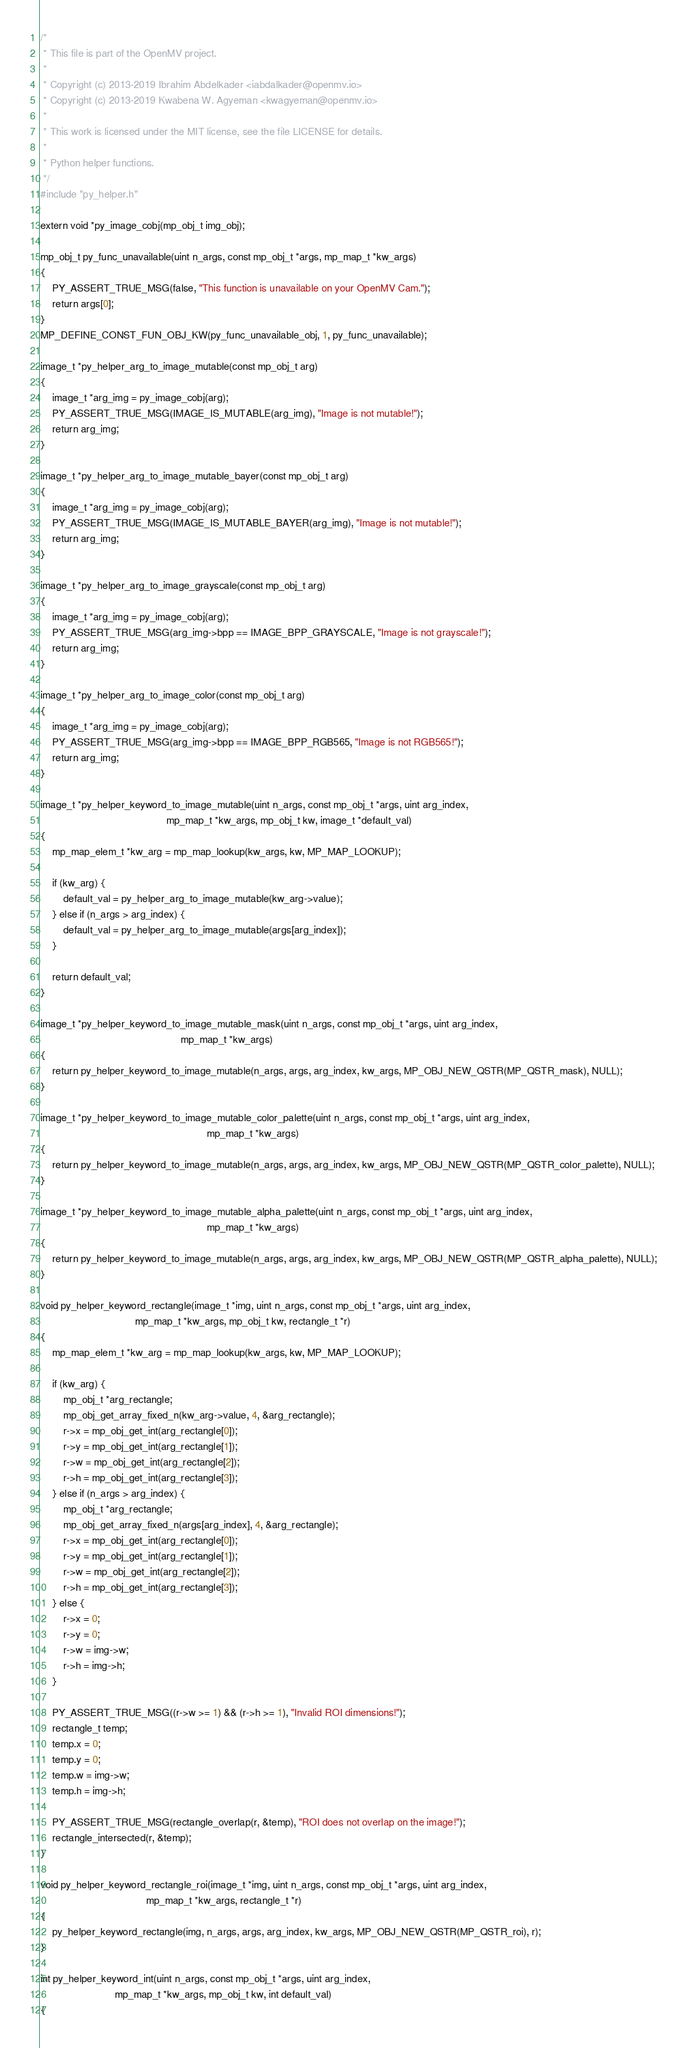Convert code to text. <code><loc_0><loc_0><loc_500><loc_500><_C_>/*
 * This file is part of the OpenMV project.
 *
 * Copyright (c) 2013-2019 Ibrahim Abdelkader <iabdalkader@openmv.io>
 * Copyright (c) 2013-2019 Kwabena W. Agyeman <kwagyeman@openmv.io>
 *
 * This work is licensed under the MIT license, see the file LICENSE for details.
 *
 * Python helper functions.
 */
#include "py_helper.h"

extern void *py_image_cobj(mp_obj_t img_obj);

mp_obj_t py_func_unavailable(uint n_args, const mp_obj_t *args, mp_map_t *kw_args)
{
    PY_ASSERT_TRUE_MSG(false, "This function is unavailable on your OpenMV Cam.");
    return args[0];
}
MP_DEFINE_CONST_FUN_OBJ_KW(py_func_unavailable_obj, 1, py_func_unavailable);

image_t *py_helper_arg_to_image_mutable(const mp_obj_t arg)
{
    image_t *arg_img = py_image_cobj(arg);
    PY_ASSERT_TRUE_MSG(IMAGE_IS_MUTABLE(arg_img), "Image is not mutable!");
    return arg_img;
}

image_t *py_helper_arg_to_image_mutable_bayer(const mp_obj_t arg)
{
    image_t *arg_img = py_image_cobj(arg);
    PY_ASSERT_TRUE_MSG(IMAGE_IS_MUTABLE_BAYER(arg_img), "Image is not mutable!");
    return arg_img;
}

image_t *py_helper_arg_to_image_grayscale(const mp_obj_t arg)
{
    image_t *arg_img = py_image_cobj(arg);
    PY_ASSERT_TRUE_MSG(arg_img->bpp == IMAGE_BPP_GRAYSCALE, "Image is not grayscale!");
    return arg_img;
}

image_t *py_helper_arg_to_image_color(const mp_obj_t arg)
{
    image_t *arg_img = py_image_cobj(arg);
    PY_ASSERT_TRUE_MSG(arg_img->bpp == IMAGE_BPP_RGB565, "Image is not RGB565!");
    return arg_img;
}

image_t *py_helper_keyword_to_image_mutable(uint n_args, const mp_obj_t *args, uint arg_index,
                                            mp_map_t *kw_args, mp_obj_t kw, image_t *default_val)
{
    mp_map_elem_t *kw_arg = mp_map_lookup(kw_args, kw, MP_MAP_LOOKUP);

    if (kw_arg) {
        default_val = py_helper_arg_to_image_mutable(kw_arg->value);
    } else if (n_args > arg_index) {
        default_val = py_helper_arg_to_image_mutable(args[arg_index]);
    }

    return default_val;
}

image_t *py_helper_keyword_to_image_mutable_mask(uint n_args, const mp_obj_t *args, uint arg_index,
                                                 mp_map_t *kw_args)
{
    return py_helper_keyword_to_image_mutable(n_args, args, arg_index, kw_args, MP_OBJ_NEW_QSTR(MP_QSTR_mask), NULL);
}

image_t *py_helper_keyword_to_image_mutable_color_palette(uint n_args, const mp_obj_t *args, uint arg_index,
                                                          mp_map_t *kw_args)
{
    return py_helper_keyword_to_image_mutable(n_args, args, arg_index, kw_args, MP_OBJ_NEW_QSTR(MP_QSTR_color_palette), NULL);
}

image_t *py_helper_keyword_to_image_mutable_alpha_palette(uint n_args, const mp_obj_t *args, uint arg_index,
                                                          mp_map_t *kw_args)
{
    return py_helper_keyword_to_image_mutable(n_args, args, arg_index, kw_args, MP_OBJ_NEW_QSTR(MP_QSTR_alpha_palette), NULL);
}

void py_helper_keyword_rectangle(image_t *img, uint n_args, const mp_obj_t *args, uint arg_index,
                                 mp_map_t *kw_args, mp_obj_t kw, rectangle_t *r)
{
    mp_map_elem_t *kw_arg = mp_map_lookup(kw_args, kw, MP_MAP_LOOKUP);

    if (kw_arg) {
        mp_obj_t *arg_rectangle;
        mp_obj_get_array_fixed_n(kw_arg->value, 4, &arg_rectangle);
        r->x = mp_obj_get_int(arg_rectangle[0]);
        r->y = mp_obj_get_int(arg_rectangle[1]);
        r->w = mp_obj_get_int(arg_rectangle[2]);
        r->h = mp_obj_get_int(arg_rectangle[3]);
    } else if (n_args > arg_index) {
        mp_obj_t *arg_rectangle;
        mp_obj_get_array_fixed_n(args[arg_index], 4, &arg_rectangle);
        r->x = mp_obj_get_int(arg_rectangle[0]);
        r->y = mp_obj_get_int(arg_rectangle[1]);
        r->w = mp_obj_get_int(arg_rectangle[2]);
        r->h = mp_obj_get_int(arg_rectangle[3]);
    } else {
        r->x = 0;
        r->y = 0;
        r->w = img->w;
        r->h = img->h;
    }

    PY_ASSERT_TRUE_MSG((r->w >= 1) && (r->h >= 1), "Invalid ROI dimensions!");
    rectangle_t temp;
    temp.x = 0;
    temp.y = 0;
    temp.w = img->w;
    temp.h = img->h;

    PY_ASSERT_TRUE_MSG(rectangle_overlap(r, &temp), "ROI does not overlap on the image!");
    rectangle_intersected(r, &temp);
}

void py_helper_keyword_rectangle_roi(image_t *img, uint n_args, const mp_obj_t *args, uint arg_index,
                                     mp_map_t *kw_args, rectangle_t *r)
{
    py_helper_keyword_rectangle(img, n_args, args, arg_index, kw_args, MP_OBJ_NEW_QSTR(MP_QSTR_roi), r);
}

int py_helper_keyword_int(uint n_args, const mp_obj_t *args, uint arg_index,
                          mp_map_t *kw_args, mp_obj_t kw, int default_val)
{</code> 